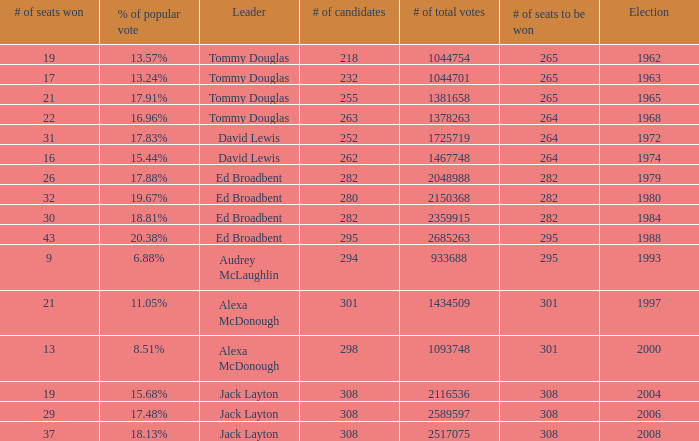Name the number of total votes for # of seats won being 30 2359915.0. 